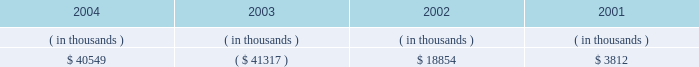Entergy louisiana , inc .
Management's financial discussion and analysis setting any of entergy louisiana's rates .
Therefore , to the extent entergy louisiana's use of the proceeds would ordinarily have reduced its rate base , no change in rate base shall be reflected for ratemaking purposes .
The sec approval for additional return of equity capital is now expired .
Entergy louisiana's receivables from or ( payables to ) the money pool were as follows as of december 31 for each of the following years: .
Money pool activity used $ 81.9 million of entergy louisiana's operating cash flow in 2004 , provided $ 60.2 million in 2003 , and used $ 15.0 million in 2002 .
See note 4 to the domestic utility companies and system energy financial statements for a description of the money pool .
Investing activities the decrease of $ 25.1 million in net cash used by investing activities in 2004 was primarily due to decreased spending on customer service projects , partially offset by increases in spending on transmission projects and fossil plant projects .
The increase of $ 56.0 million in net cash used by investing activities in 2003 was primarily due to increased spending on customer service , transmission , and nuclear projects .
Financing activities the decrease of $ 404.4 million in net cash used by financing activities in 2004 was primarily due to : 2022 the net issuance of $ 98.0 million of long-term debt in 2004 compared to the retirement of $ 261.0 million in 2022 a principal payment of $ 14.8 million in 2004 for the waterford lease obligation compared to a principal payment of $ 35.4 million in 2003 ; and 2022 a decrease of $ 29.0 million in common stock dividends paid .
The decrease of $ 105.5 million in net cash used by financing activities in 2003 was primarily due to : 2022 a decrease of $ 125.9 million in common stock dividends paid ; and 2022 the repurchase of $ 120 million of common stock from entergy corporation in 2002 .
The decrease in net cash used in 2003 was partially offset by the following : 2022 the retirement in 2003 of $ 150 million of 8.5% ( 8.5 % ) series first mortgage bonds compared to the net retirement of $ 134.6 million of first mortgage bonds in 2002 ; and 2022 principal payments of $ 35.4 million in 2003 for the waterford 3 lease obligation compared to principal payments of $ 15.9 million in 2002 .
See note 5 to the domestic utility companies and system energy financial statements for details of long-term debt .
Uses of capital entergy louisiana requires capital resources for : 2022 construction and other capital investments ; 2022 debt and preferred stock maturities ; 2022 working capital purposes , including the financing of fuel and purchased power costs ; and 2022 dividend and interest payments. .
What is the percent change in receivables from or ( payables to ) the money pool from 2001 to 2002? 
Computations: ((18854 - 3812) / 3812)
Answer: 3.94596. 